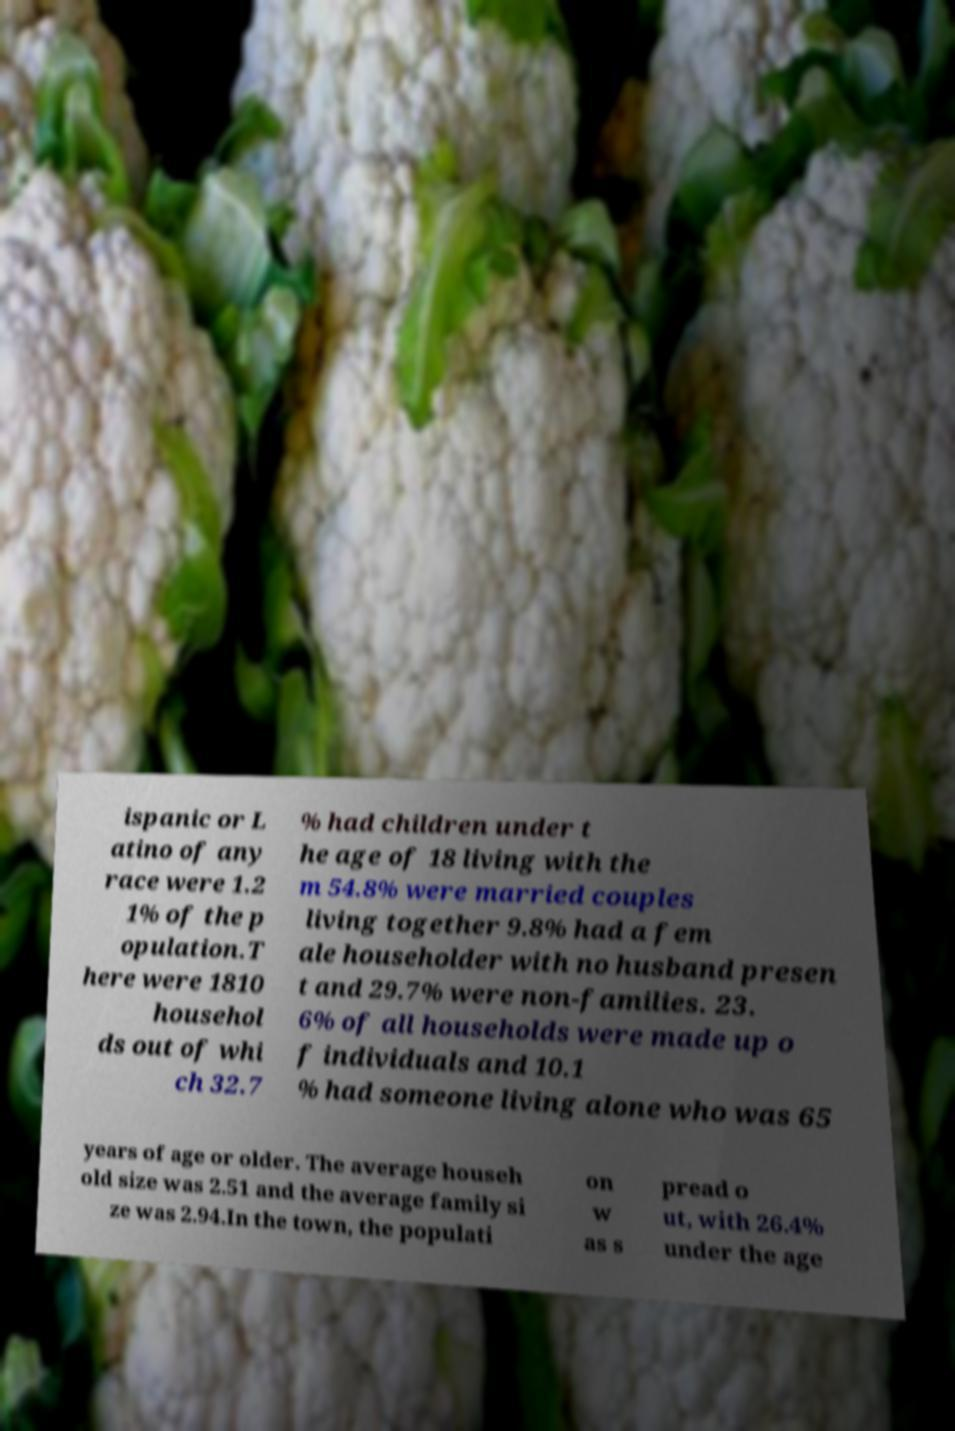There's text embedded in this image that I need extracted. Can you transcribe it verbatim? ispanic or L atino of any race were 1.2 1% of the p opulation.T here were 1810 househol ds out of whi ch 32.7 % had children under t he age of 18 living with the m 54.8% were married couples living together 9.8% had a fem ale householder with no husband presen t and 29.7% were non-families. 23. 6% of all households were made up o f individuals and 10.1 % had someone living alone who was 65 years of age or older. The average househ old size was 2.51 and the average family si ze was 2.94.In the town, the populati on w as s pread o ut, with 26.4% under the age 